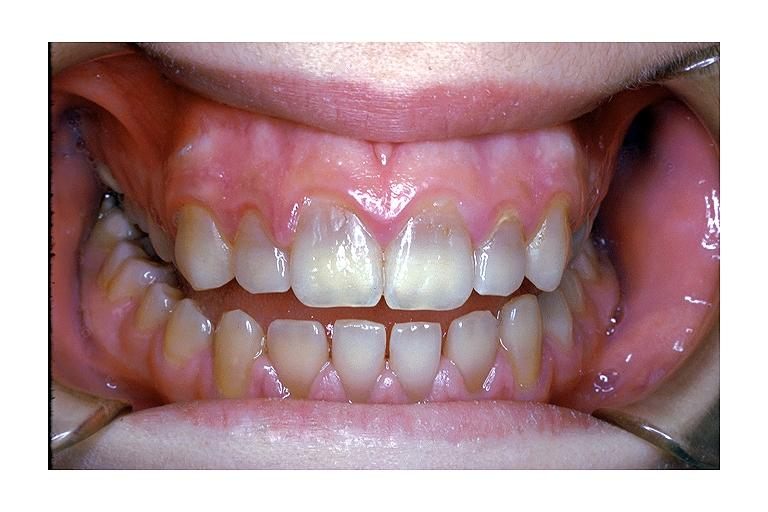what induced discoloration?
Answer the question using a single word or phrase. Tetracycline 